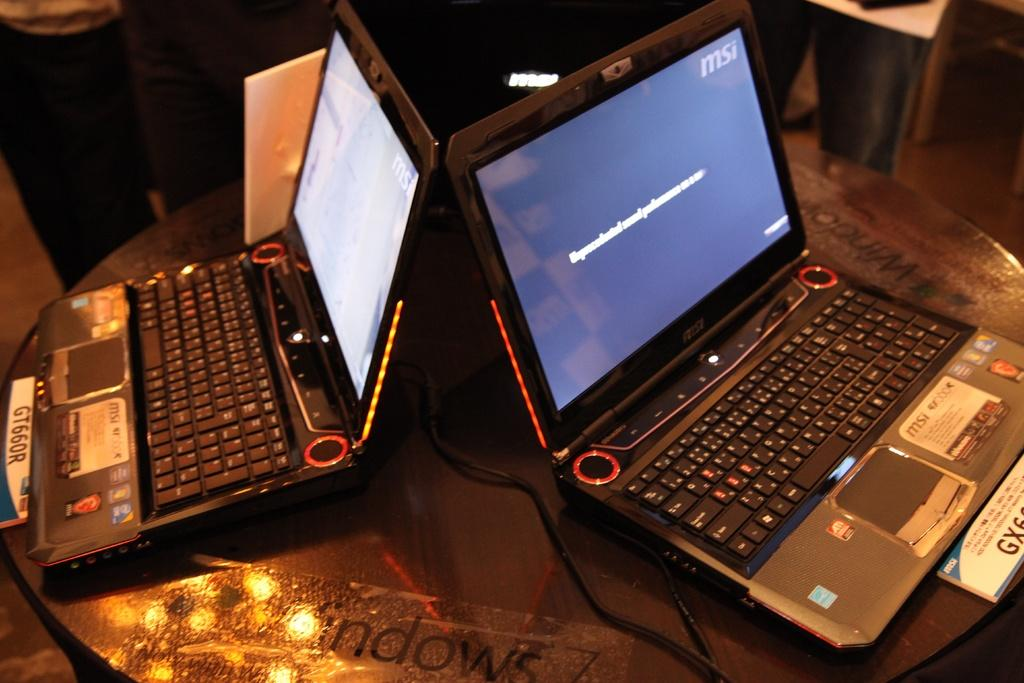<image>
Render a clear and concise summary of the photo. two laptops on a table, one of them has the letters MSI on. 